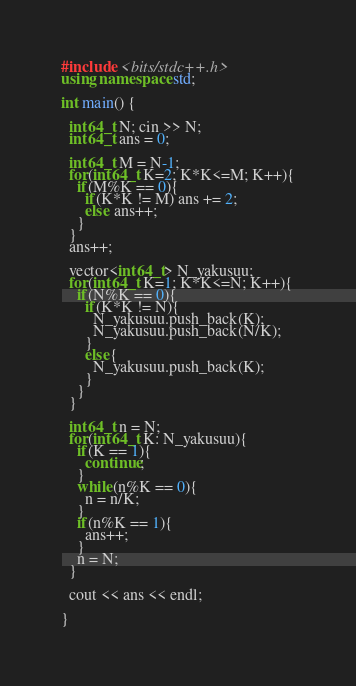Convert code to text. <code><loc_0><loc_0><loc_500><loc_500><_C++_>#include <bits/stdc++.h>
using namespace std;

int main() {
  
  int64_t N; cin >> N;
  int64_t ans = 0;
  
  int64_t M = N-1;
  for(int64_t K=2; K*K<=M; K++){
    if(M%K == 0){
      if(K*K != M) ans += 2;
      else ans++;
    }
  }
  ans++;

  vector<int64_t> N_yakusuu;
  for(int64_t K=1; K*K<=N; K++){
    if(N%K == 0){
      if(K*K != N){
        N_yakusuu.push_back(K);
        N_yakusuu.push_back(N/K);
      }
      else{
        N_yakusuu.push_back(K);
      }
    }
  }
  
  int64_t n = N;
  for(int64_t K: N_yakusuu){
    if(K == 1){
      continue;
    }
    while(n%K == 0){
      n = n/K;
    }
    if(n%K == 1){
      ans++;
    }
    n = N;
  }
  
  cout << ans << endl;
  
}</code> 